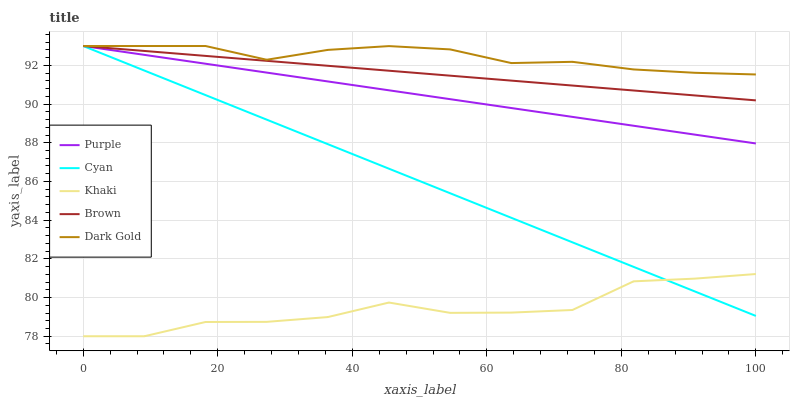Does Khaki have the minimum area under the curve?
Answer yes or no. Yes. Does Dark Gold have the maximum area under the curve?
Answer yes or no. Yes. Does Cyan have the minimum area under the curve?
Answer yes or no. No. Does Cyan have the maximum area under the curve?
Answer yes or no. No. Is Cyan the smoothest?
Answer yes or no. Yes. Is Khaki the roughest?
Answer yes or no. Yes. Is Khaki the smoothest?
Answer yes or no. No. Is Cyan the roughest?
Answer yes or no. No. Does Cyan have the lowest value?
Answer yes or no. No. Does Khaki have the highest value?
Answer yes or no. No. Is Khaki less than Purple?
Answer yes or no. Yes. Is Purple greater than Khaki?
Answer yes or no. Yes. Does Khaki intersect Purple?
Answer yes or no. No. 